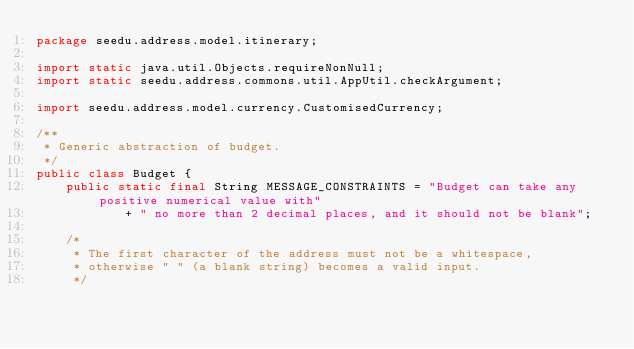<code> <loc_0><loc_0><loc_500><loc_500><_Java_>package seedu.address.model.itinerary;

import static java.util.Objects.requireNonNull;
import static seedu.address.commons.util.AppUtil.checkArgument;

import seedu.address.model.currency.CustomisedCurrency;

/**
 * Generic abstraction of budget.
 */
public class Budget {
    public static final String MESSAGE_CONSTRAINTS = "Budget can take any positive numerical value with"
            + " no more than 2 decimal places, and it should not be blank";

    /*
     * The first character of the address must not be a whitespace,
     * otherwise " " (a blank string) becomes a valid input.
     */
</code> 